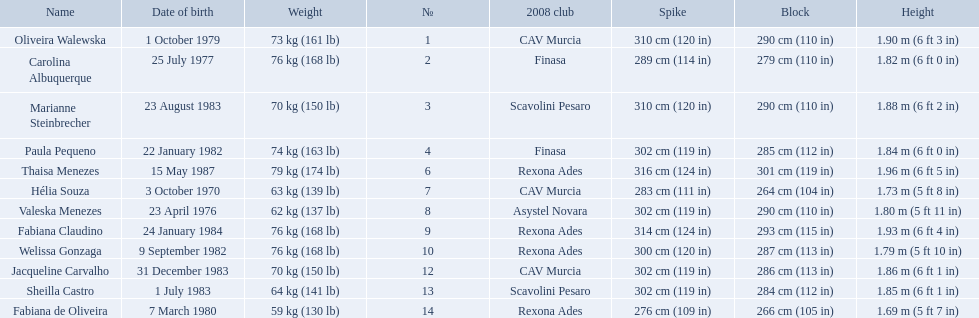How much does fabiana de oliveira weigh? 76 kg (168 lb). How much does helia souza weigh? 63 kg (139 lb). How much does sheilla castro weigh? 64 kg (141 lb). Whose weight did the original question asker incorrectly believe to be the heaviest (they are the second heaviest)? Sheilla Castro. 